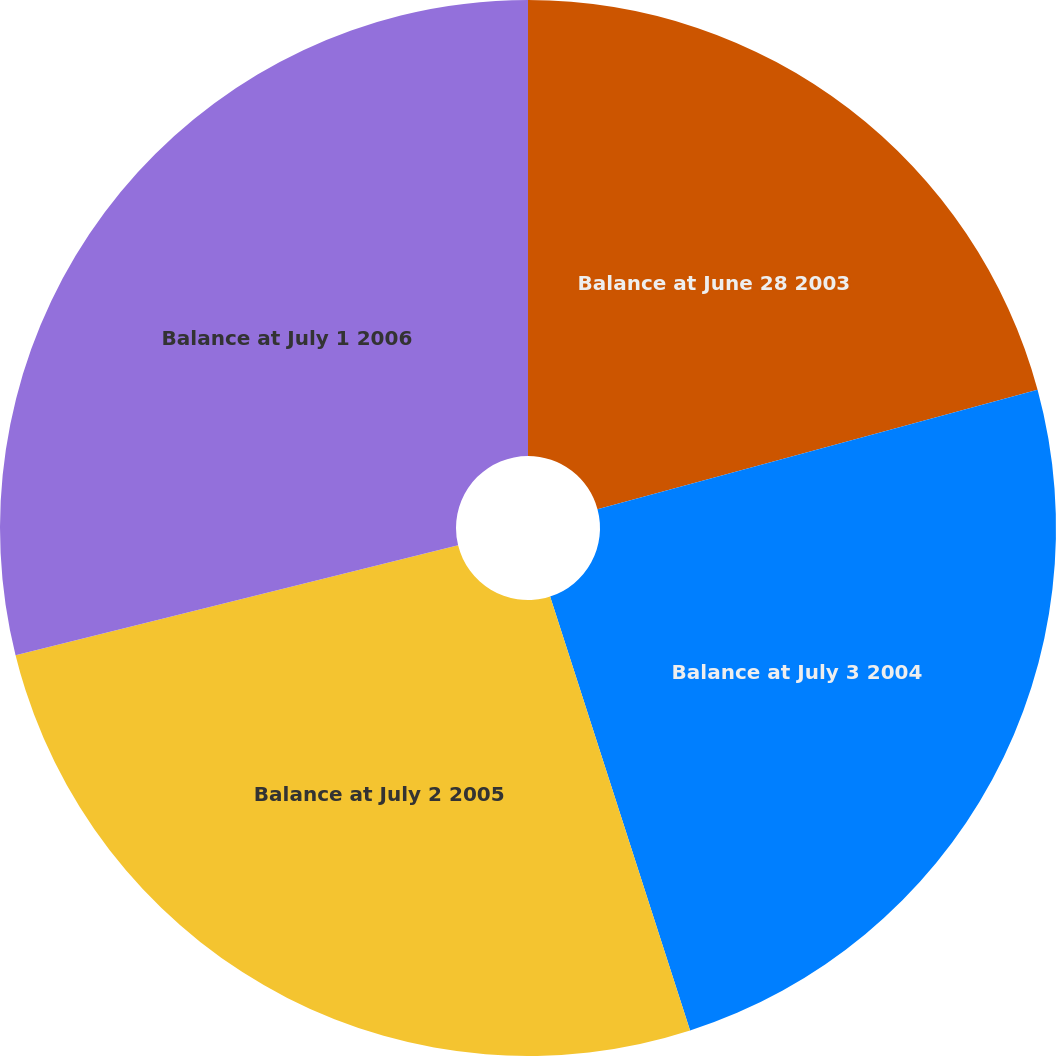Convert chart to OTSL. <chart><loc_0><loc_0><loc_500><loc_500><pie_chart><fcel>Balance at June 28 2003<fcel>Balance at July 3 2004<fcel>Balance at July 2 2005<fcel>Balance at July 1 2006<nl><fcel>20.78%<fcel>24.25%<fcel>26.09%<fcel>28.87%<nl></chart> 